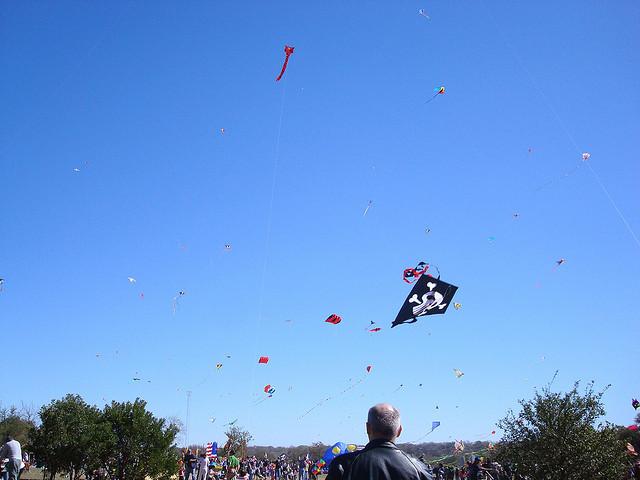What design is on the black kite?
Give a very brief answer. Skull and bones. Is the man in the foreground balding?
Quick response, please. Yes. Are they fighting kites against each other?
Keep it brief. No. Is the man facing the camera?
Concise answer only. No. 